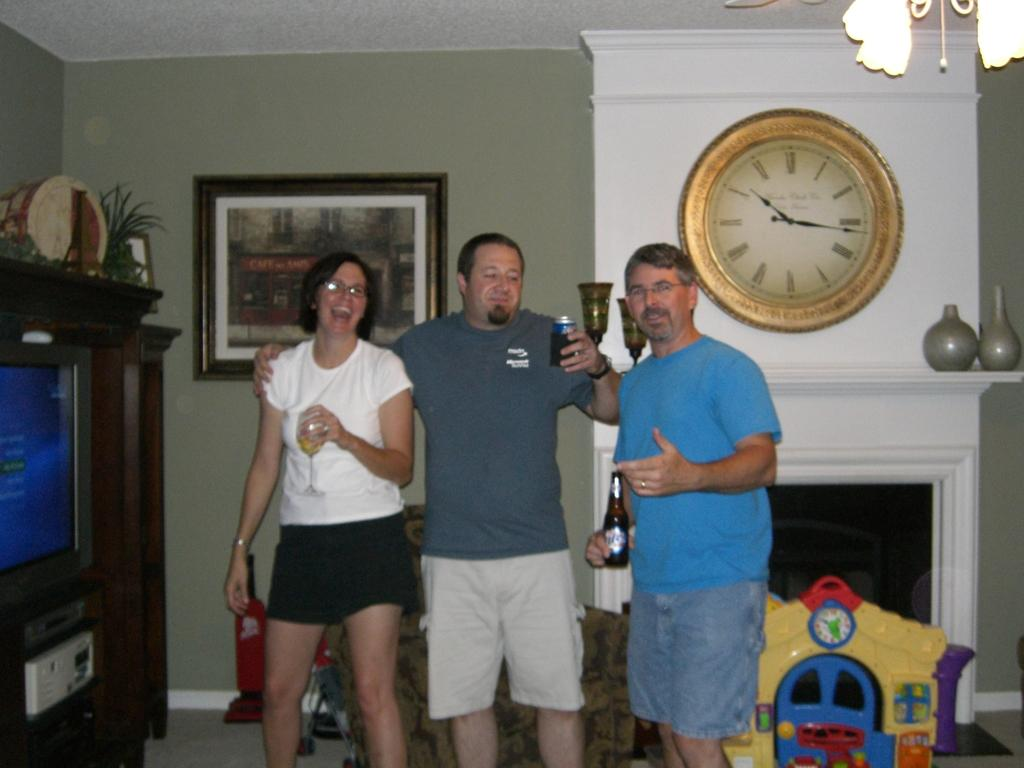Provide a one-sentence caption for the provided image. A group of boomers pose near a large wall clock showing 10:16 as the time. 